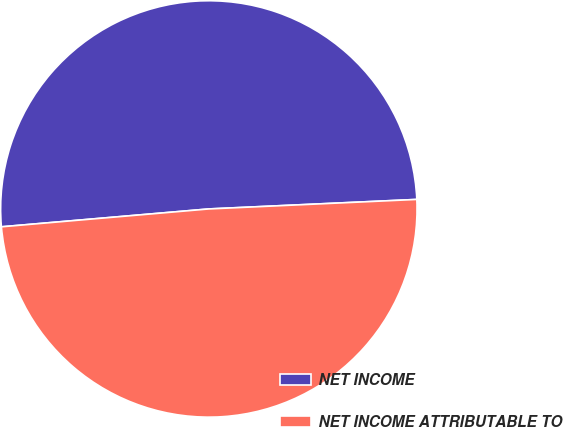Convert chart. <chart><loc_0><loc_0><loc_500><loc_500><pie_chart><fcel>NET INCOME<fcel>NET INCOME ATTRIBUTABLE TO<nl><fcel>50.64%<fcel>49.36%<nl></chart> 